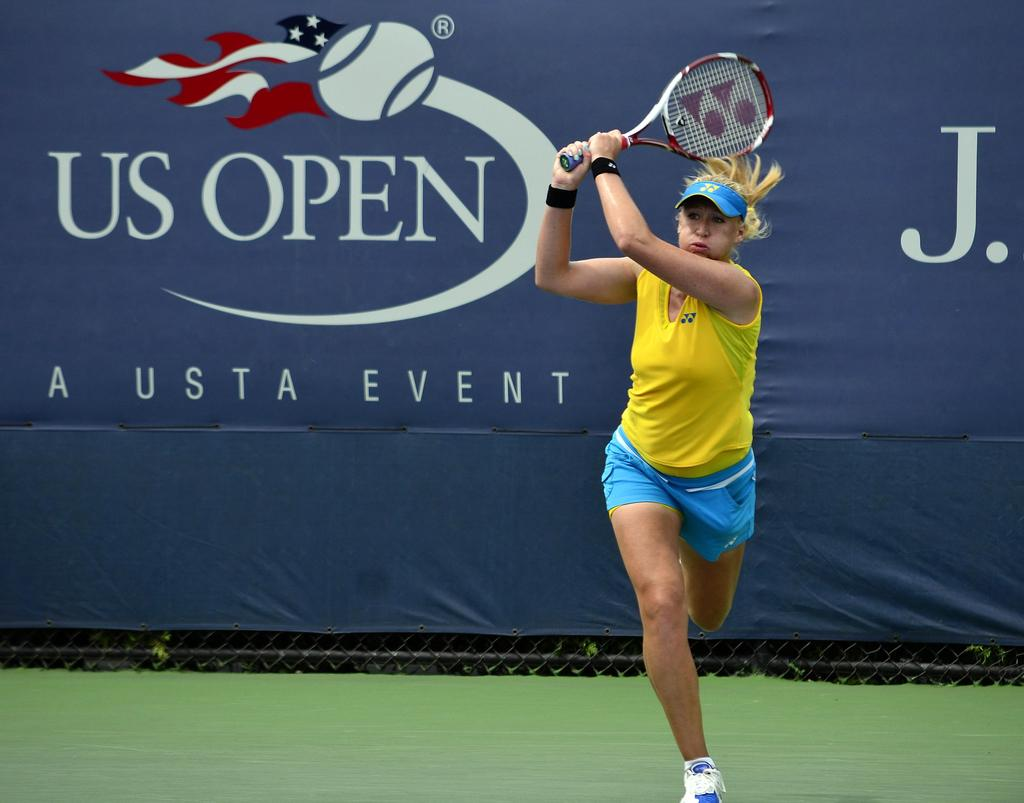What is the main subject of the image? The main subject of the image is a player. What is the player holding in the image? The player is holding a bat with her two hands. What else can be seen in the image besides the player? There is a banner in the image. What information is displayed on the banner? The banner has a name on it. What type of hill can be seen in the background of the image? There is no hill visible in the image; it only features a player, a bat, and a banner. What punishment is the player receiving for not following the rules in the image? There is no indication of punishment in the image; the player is simply holding a bat. 